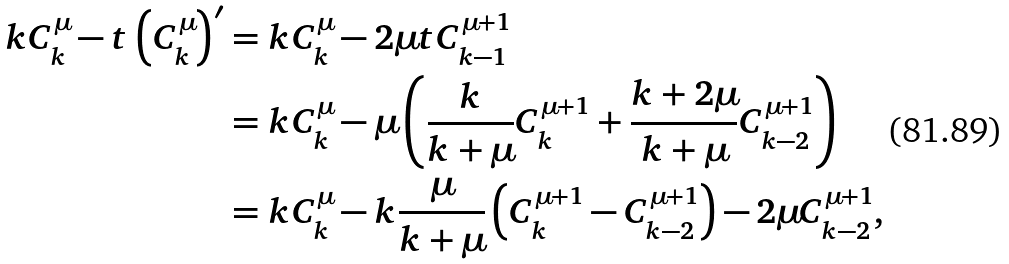<formula> <loc_0><loc_0><loc_500><loc_500>k C _ { k } ^ { \mu } - t \left ( C _ { k } ^ { \mu } \right ) ^ { \prime } & = k C _ { k } ^ { \mu } - 2 \mu t C _ { k - 1 } ^ { \mu + 1 } \\ & = k C _ { k } ^ { \mu } - \mu \left ( \frac { k } { k + \mu } C _ { k } ^ { \mu + 1 } + \frac { k + 2 \mu } { k + \mu } C _ { k - 2 } ^ { \mu + 1 } \right ) \\ & = k C _ { k } ^ { \mu } - k \frac { \mu } { k + \mu } \left ( C _ { k } ^ { \mu + 1 } - C _ { k - 2 } ^ { \mu + 1 } \right ) - 2 \mu C _ { k - 2 } ^ { \mu + 1 } ,</formula> 